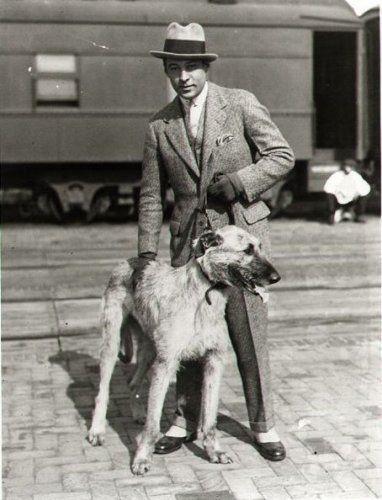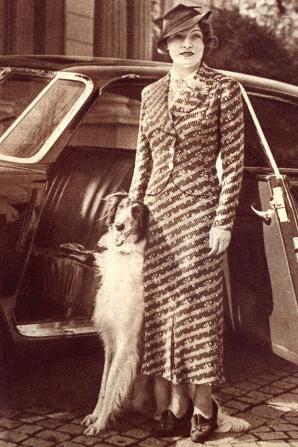The first image is the image on the left, the second image is the image on the right. For the images displayed, is the sentence "A vintage image shows a woman in a non-floor-length skirt, jacket and hat standing outdoors next to one afghan hound." factually correct? Answer yes or no. Yes. The first image is the image on the left, the second image is the image on the right. Evaluate the accuracy of this statement regarding the images: "A woman is standing with a single dog in the image on the right.". Is it true? Answer yes or no. Yes. 